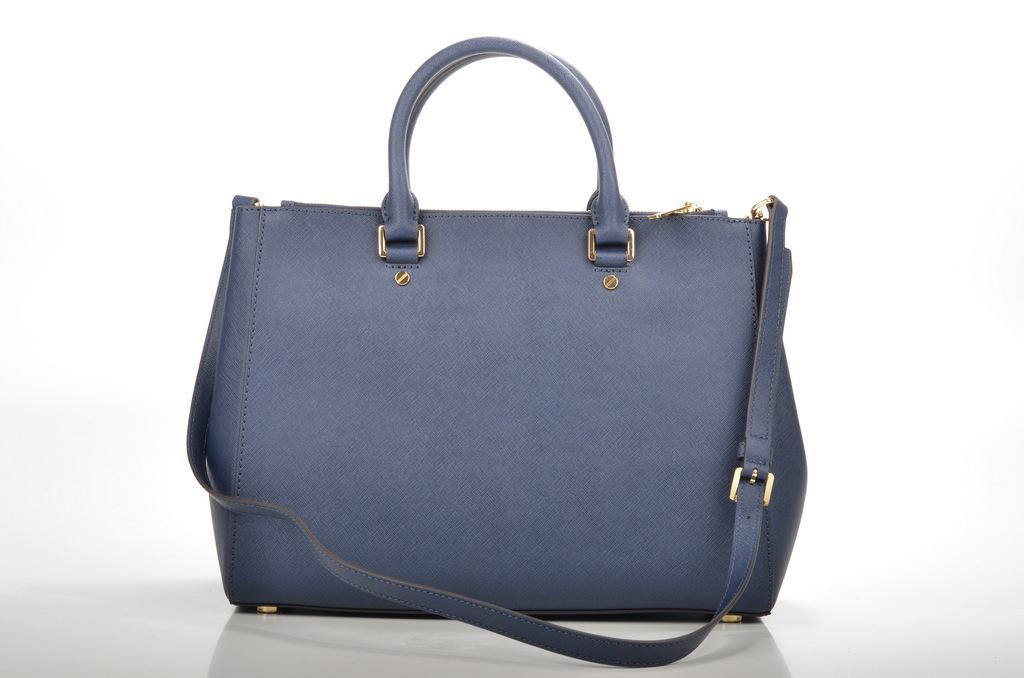What color is the handbag in the picture? The handbag is blue. How is the handbag being emphasized in the picture? The handbag is highlighted. What is the color of the surface on which the handbag is placed? The handbag is placed on a white surface. Can you tell me how many boats are docked at the harbor in the image? There is no harbor or boats present in the image; it features a blue handbag on a white surface. 